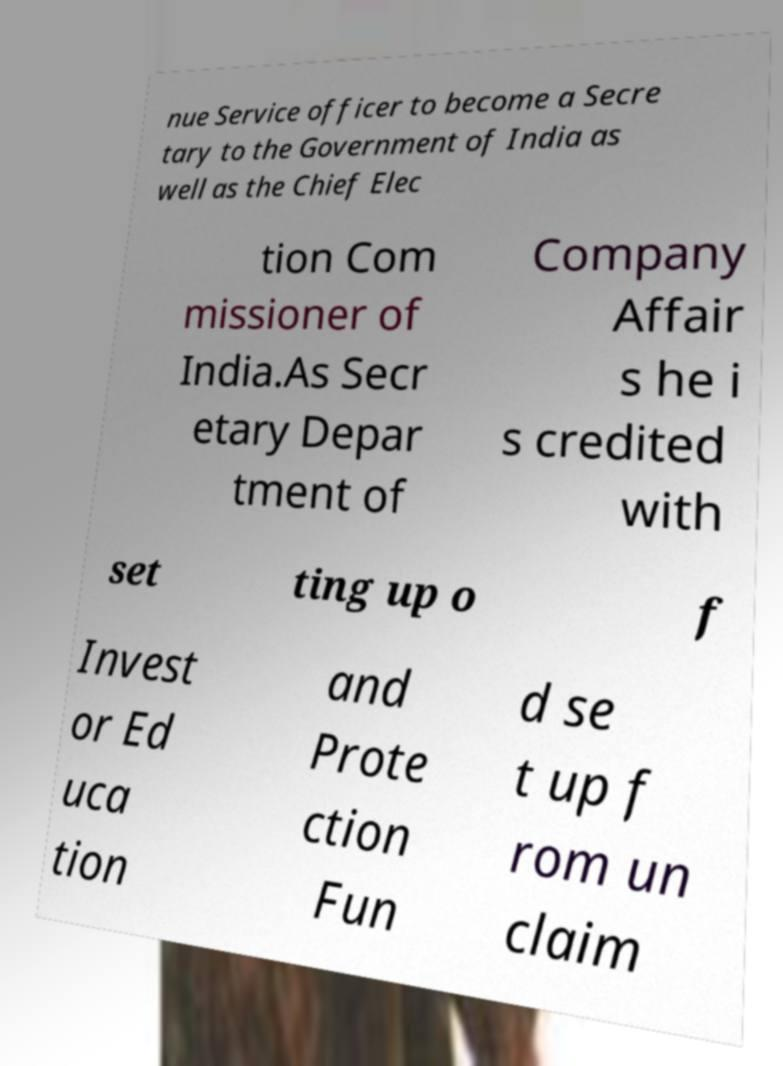Please identify and transcribe the text found in this image. nue Service officer to become a Secre tary to the Government of India as well as the Chief Elec tion Com missioner of India.As Secr etary Depar tment of Company Affair s he i s credited with set ting up o f Invest or Ed uca tion and Prote ction Fun d se t up f rom un claim 